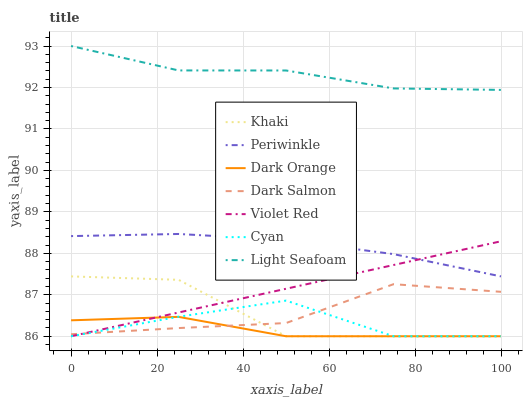Does Dark Orange have the minimum area under the curve?
Answer yes or no. Yes. Does Light Seafoam have the maximum area under the curve?
Answer yes or no. Yes. Does Violet Red have the minimum area under the curve?
Answer yes or no. No. Does Violet Red have the maximum area under the curve?
Answer yes or no. No. Is Violet Red the smoothest?
Answer yes or no. Yes. Is Khaki the roughest?
Answer yes or no. Yes. Is Khaki the smoothest?
Answer yes or no. No. Is Violet Red the roughest?
Answer yes or no. No. Does Dark Orange have the lowest value?
Answer yes or no. Yes. Does Dark Salmon have the lowest value?
Answer yes or no. No. Does Light Seafoam have the highest value?
Answer yes or no. Yes. Does Violet Red have the highest value?
Answer yes or no. No. Is Dark Salmon less than Light Seafoam?
Answer yes or no. Yes. Is Light Seafoam greater than Khaki?
Answer yes or no. Yes. Does Dark Salmon intersect Cyan?
Answer yes or no. Yes. Is Dark Salmon less than Cyan?
Answer yes or no. No. Is Dark Salmon greater than Cyan?
Answer yes or no. No. Does Dark Salmon intersect Light Seafoam?
Answer yes or no. No. 